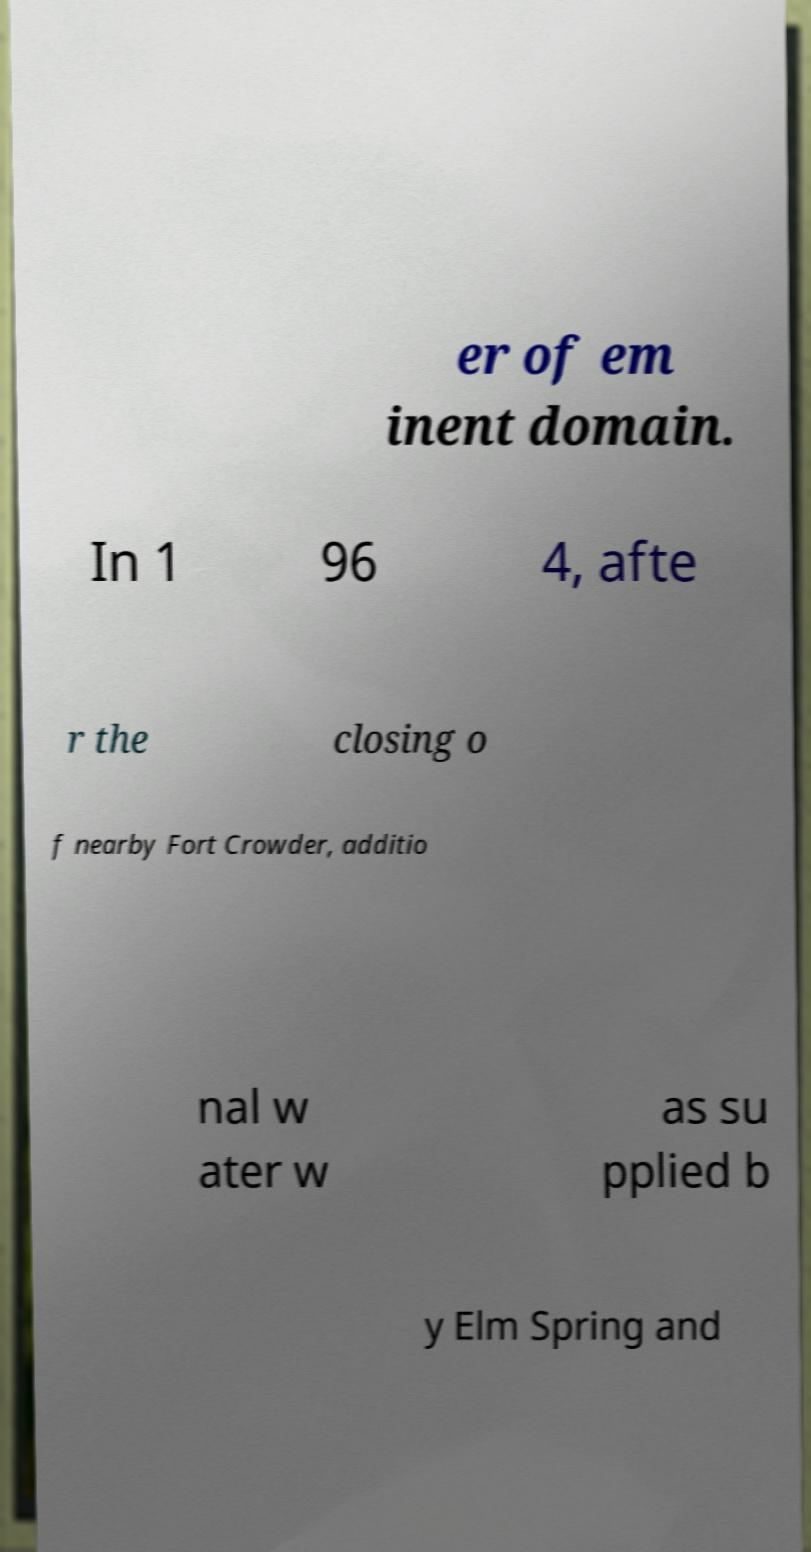For documentation purposes, I need the text within this image transcribed. Could you provide that? er of em inent domain. In 1 96 4, afte r the closing o f nearby Fort Crowder, additio nal w ater w as su pplied b y Elm Spring and 